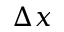Convert formula to latex. <formula><loc_0><loc_0><loc_500><loc_500>\Delta { x }</formula> 